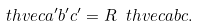Convert formula to latex. <formula><loc_0><loc_0><loc_500><loc_500>\ t h v e c { a ^ { \prime } } { b ^ { \prime } } { c ^ { \prime } } = R \ t h v e c { a } { b } { c } .</formula> 